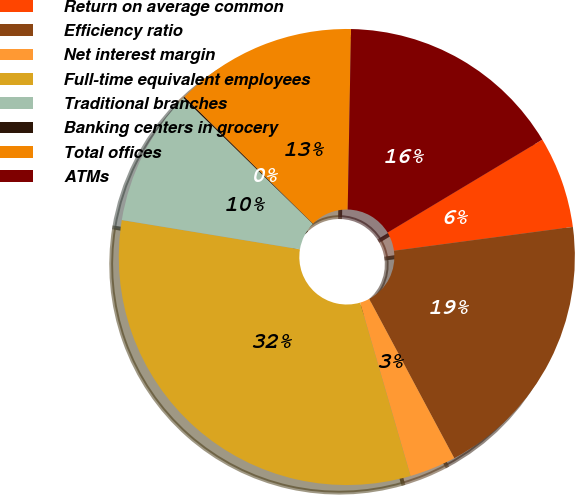<chart> <loc_0><loc_0><loc_500><loc_500><pie_chart><fcel>Return on average common<fcel>Efficiency ratio<fcel>Net interest margin<fcel>Full-time equivalent employees<fcel>Traditional branches<fcel>Banking centers in grocery<fcel>Total offices<fcel>ATMs<nl><fcel>6.5%<fcel>19.3%<fcel>3.3%<fcel>32.1%<fcel>9.7%<fcel>0.1%<fcel>12.9%<fcel>16.1%<nl></chart> 